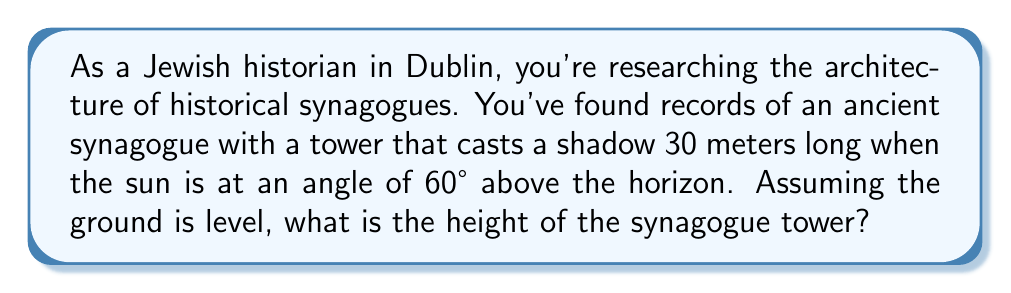Solve this math problem. Let's approach this step-by-step using trigonometry:

1) We can represent this scenario with a right triangle, where:
   - The tower is the vertical side (height we want to find)
   - The shadow is the horizontal side (30 meters)
   - The sun's rays form the hypotenuse

2) The angle between the ground and the sun's rays is 60°

3) In this right triangle, we know:
   - The adjacent side (shadow length) = 30 meters
   - The angle = 60°
   - We need to find the opposite side (tower height)

4) This calls for the tangent function:

   $$\tan(\theta) = \frac{\text{opposite}}{\text{adjacent}}$$

5) Plugging in our known values:

   $$\tan(60°) = \frac{\text{tower height}}{30}$$

6) We know that $\tan(60°) = \sqrt{3}$, so:

   $$\sqrt{3} = \frac{\text{tower height}}{30}$$

7) Solve for the tower height:

   $$\text{tower height} = 30 \sqrt{3}$$

8) Calculate the final value:

   $$\text{tower height} = 30 \sqrt{3} \approx 51.96 \text{ meters}$$

[asy]
import geometry;

size(200);
pair A = (0,0), B = (5,0), C = (0,8.66);
draw(A--B--C--A);
draw(rightanglemark(A,B,C,20));
label("30 m", (B--A), S);
label("Tower height", (A--C), W);
label("60°", A, SE);
draw(arc(A,0.8,0,60), Arrow);
[/asy]
Answer: $51.96 \text{ meters}$ 